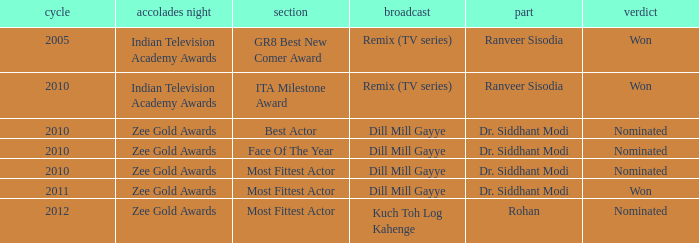Which show was nominated for the ITA Milestone Award at the Indian Television Academy Awards? Remix (TV series). 